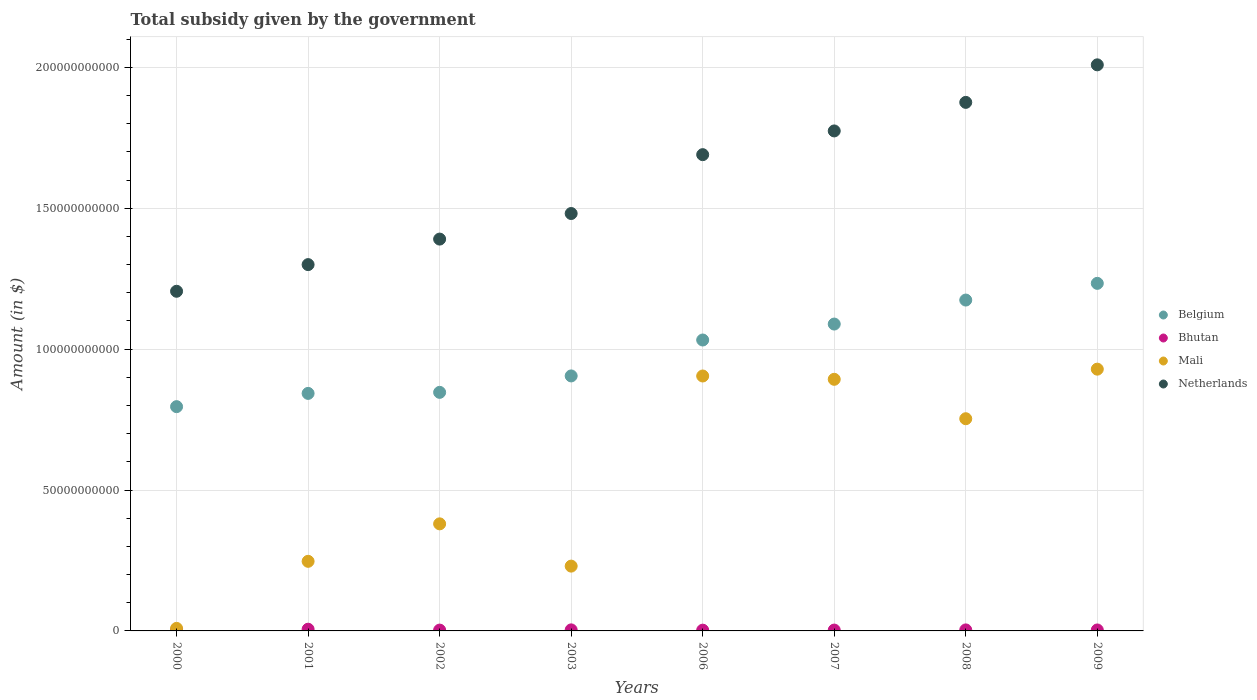How many different coloured dotlines are there?
Make the answer very short. 4. Is the number of dotlines equal to the number of legend labels?
Ensure brevity in your answer.  Yes. What is the total revenue collected by the government in Mali in 2008?
Give a very brief answer. 7.53e+1. Across all years, what is the maximum total revenue collected by the government in Mali?
Your answer should be very brief. 9.29e+1. Across all years, what is the minimum total revenue collected by the government in Belgium?
Provide a succinct answer. 7.96e+1. In which year was the total revenue collected by the government in Belgium minimum?
Provide a succinct answer. 2000. What is the total total revenue collected by the government in Belgium in the graph?
Provide a short and direct response. 7.92e+11. What is the difference between the total revenue collected by the government in Netherlands in 2001 and that in 2002?
Make the answer very short. -9.06e+09. What is the difference between the total revenue collected by the government in Netherlands in 2002 and the total revenue collected by the government in Mali in 2003?
Provide a succinct answer. 1.16e+11. What is the average total revenue collected by the government in Bhutan per year?
Your response must be concise. 3.51e+08. In the year 2003, what is the difference between the total revenue collected by the government in Mali and total revenue collected by the government in Netherlands?
Your response must be concise. -1.25e+11. What is the ratio of the total revenue collected by the government in Mali in 2003 to that in 2006?
Offer a very short reply. 0.25. Is the difference between the total revenue collected by the government in Mali in 2000 and 2002 greater than the difference between the total revenue collected by the government in Netherlands in 2000 and 2002?
Your answer should be compact. No. What is the difference between the highest and the second highest total revenue collected by the government in Bhutan?
Make the answer very short. 2.35e+08. What is the difference between the highest and the lowest total revenue collected by the government in Bhutan?
Offer a very short reply. 3.51e+08. Is it the case that in every year, the sum of the total revenue collected by the government in Mali and total revenue collected by the government in Belgium  is greater than the sum of total revenue collected by the government in Bhutan and total revenue collected by the government in Netherlands?
Offer a terse response. No. Is it the case that in every year, the sum of the total revenue collected by the government in Bhutan and total revenue collected by the government in Mali  is greater than the total revenue collected by the government in Netherlands?
Provide a succinct answer. No. How many dotlines are there?
Keep it short and to the point. 4. Are the values on the major ticks of Y-axis written in scientific E-notation?
Provide a short and direct response. No. Does the graph contain any zero values?
Make the answer very short. No. Does the graph contain grids?
Provide a succinct answer. Yes. Where does the legend appear in the graph?
Keep it short and to the point. Center right. How are the legend labels stacked?
Keep it short and to the point. Vertical. What is the title of the graph?
Make the answer very short. Total subsidy given by the government. Does "Bolivia" appear as one of the legend labels in the graph?
Ensure brevity in your answer.  No. What is the label or title of the X-axis?
Make the answer very short. Years. What is the label or title of the Y-axis?
Ensure brevity in your answer.  Amount (in $). What is the Amount (in $) of Belgium in 2000?
Ensure brevity in your answer.  7.96e+1. What is the Amount (in $) in Bhutan in 2000?
Offer a very short reply. 2.56e+08. What is the Amount (in $) in Mali in 2000?
Ensure brevity in your answer.  9.00e+08. What is the Amount (in $) of Netherlands in 2000?
Ensure brevity in your answer.  1.21e+11. What is the Amount (in $) in Belgium in 2001?
Keep it short and to the point. 8.43e+1. What is the Amount (in $) of Bhutan in 2001?
Your answer should be very brief. 6.07e+08. What is the Amount (in $) of Mali in 2001?
Provide a short and direct response. 2.47e+1. What is the Amount (in $) of Netherlands in 2001?
Your answer should be very brief. 1.30e+11. What is the Amount (in $) in Belgium in 2002?
Offer a very short reply. 8.47e+1. What is the Amount (in $) of Bhutan in 2002?
Give a very brief answer. 2.94e+08. What is the Amount (in $) in Mali in 2002?
Ensure brevity in your answer.  3.80e+1. What is the Amount (in $) in Netherlands in 2002?
Your answer should be very brief. 1.39e+11. What is the Amount (in $) in Belgium in 2003?
Your response must be concise. 9.05e+1. What is the Amount (in $) in Bhutan in 2003?
Make the answer very short. 3.72e+08. What is the Amount (in $) of Mali in 2003?
Ensure brevity in your answer.  2.30e+1. What is the Amount (in $) in Netherlands in 2003?
Make the answer very short. 1.48e+11. What is the Amount (in $) of Belgium in 2006?
Ensure brevity in your answer.  1.03e+11. What is the Amount (in $) in Bhutan in 2006?
Offer a very short reply. 2.71e+08. What is the Amount (in $) of Mali in 2006?
Your answer should be very brief. 9.05e+1. What is the Amount (in $) of Netherlands in 2006?
Make the answer very short. 1.69e+11. What is the Amount (in $) of Belgium in 2007?
Your response must be concise. 1.09e+11. What is the Amount (in $) of Bhutan in 2007?
Your answer should be compact. 3.05e+08. What is the Amount (in $) in Mali in 2007?
Give a very brief answer. 8.93e+1. What is the Amount (in $) of Netherlands in 2007?
Your response must be concise. 1.77e+11. What is the Amount (in $) of Belgium in 2008?
Ensure brevity in your answer.  1.17e+11. What is the Amount (in $) of Bhutan in 2008?
Provide a succinct answer. 3.60e+08. What is the Amount (in $) of Mali in 2008?
Make the answer very short. 7.53e+1. What is the Amount (in $) in Netherlands in 2008?
Make the answer very short. 1.88e+11. What is the Amount (in $) in Belgium in 2009?
Your answer should be compact. 1.23e+11. What is the Amount (in $) of Bhutan in 2009?
Your response must be concise. 3.42e+08. What is the Amount (in $) of Mali in 2009?
Provide a short and direct response. 9.29e+1. What is the Amount (in $) of Netherlands in 2009?
Offer a terse response. 2.01e+11. Across all years, what is the maximum Amount (in $) in Belgium?
Keep it short and to the point. 1.23e+11. Across all years, what is the maximum Amount (in $) of Bhutan?
Your response must be concise. 6.07e+08. Across all years, what is the maximum Amount (in $) of Mali?
Your answer should be compact. 9.29e+1. Across all years, what is the maximum Amount (in $) in Netherlands?
Your answer should be very brief. 2.01e+11. Across all years, what is the minimum Amount (in $) of Belgium?
Your response must be concise. 7.96e+1. Across all years, what is the minimum Amount (in $) of Bhutan?
Offer a very short reply. 2.56e+08. Across all years, what is the minimum Amount (in $) of Mali?
Provide a short and direct response. 9.00e+08. Across all years, what is the minimum Amount (in $) in Netherlands?
Make the answer very short. 1.21e+11. What is the total Amount (in $) of Belgium in the graph?
Provide a succinct answer. 7.92e+11. What is the total Amount (in $) in Bhutan in the graph?
Make the answer very short. 2.80e+09. What is the total Amount (in $) in Mali in the graph?
Keep it short and to the point. 4.35e+11. What is the total Amount (in $) in Netherlands in the graph?
Offer a very short reply. 1.27e+12. What is the difference between the Amount (in $) of Belgium in 2000 and that in 2001?
Your answer should be very brief. -4.70e+09. What is the difference between the Amount (in $) of Bhutan in 2000 and that in 2001?
Keep it short and to the point. -3.51e+08. What is the difference between the Amount (in $) of Mali in 2000 and that in 2001?
Your response must be concise. -2.38e+1. What is the difference between the Amount (in $) of Netherlands in 2000 and that in 2001?
Offer a very short reply. -9.46e+09. What is the difference between the Amount (in $) in Belgium in 2000 and that in 2002?
Provide a short and direct response. -5.08e+09. What is the difference between the Amount (in $) of Bhutan in 2000 and that in 2002?
Provide a short and direct response. -3.80e+07. What is the difference between the Amount (in $) in Mali in 2000 and that in 2002?
Provide a succinct answer. -3.71e+1. What is the difference between the Amount (in $) of Netherlands in 2000 and that in 2002?
Keep it short and to the point. -1.85e+1. What is the difference between the Amount (in $) in Belgium in 2000 and that in 2003?
Your response must be concise. -1.09e+1. What is the difference between the Amount (in $) in Bhutan in 2000 and that in 2003?
Your answer should be compact. -1.16e+08. What is the difference between the Amount (in $) in Mali in 2000 and that in 2003?
Give a very brief answer. -2.21e+1. What is the difference between the Amount (in $) in Netherlands in 2000 and that in 2003?
Your answer should be compact. -2.76e+1. What is the difference between the Amount (in $) in Belgium in 2000 and that in 2006?
Provide a succinct answer. -2.37e+1. What is the difference between the Amount (in $) of Bhutan in 2000 and that in 2006?
Keep it short and to the point. -1.47e+07. What is the difference between the Amount (in $) of Mali in 2000 and that in 2006?
Offer a terse response. -8.96e+1. What is the difference between the Amount (in $) of Netherlands in 2000 and that in 2006?
Keep it short and to the point. -4.85e+1. What is the difference between the Amount (in $) of Belgium in 2000 and that in 2007?
Offer a very short reply. -2.93e+1. What is the difference between the Amount (in $) in Bhutan in 2000 and that in 2007?
Give a very brief answer. -4.88e+07. What is the difference between the Amount (in $) of Mali in 2000 and that in 2007?
Make the answer very short. -8.84e+1. What is the difference between the Amount (in $) in Netherlands in 2000 and that in 2007?
Provide a succinct answer. -5.69e+1. What is the difference between the Amount (in $) of Belgium in 2000 and that in 2008?
Keep it short and to the point. -3.78e+1. What is the difference between the Amount (in $) in Bhutan in 2000 and that in 2008?
Your answer should be very brief. -1.04e+08. What is the difference between the Amount (in $) in Mali in 2000 and that in 2008?
Give a very brief answer. -7.44e+1. What is the difference between the Amount (in $) in Netherlands in 2000 and that in 2008?
Provide a succinct answer. -6.70e+1. What is the difference between the Amount (in $) of Belgium in 2000 and that in 2009?
Ensure brevity in your answer.  -4.38e+1. What is the difference between the Amount (in $) in Bhutan in 2000 and that in 2009?
Offer a very short reply. -8.59e+07. What is the difference between the Amount (in $) of Mali in 2000 and that in 2009?
Your answer should be compact. -9.20e+1. What is the difference between the Amount (in $) in Netherlands in 2000 and that in 2009?
Offer a terse response. -8.04e+1. What is the difference between the Amount (in $) in Belgium in 2001 and that in 2002?
Your answer should be very brief. -3.72e+08. What is the difference between the Amount (in $) in Bhutan in 2001 and that in 2002?
Offer a very short reply. 3.13e+08. What is the difference between the Amount (in $) in Mali in 2001 and that in 2002?
Make the answer very short. -1.33e+1. What is the difference between the Amount (in $) in Netherlands in 2001 and that in 2002?
Offer a very short reply. -9.06e+09. What is the difference between the Amount (in $) in Belgium in 2001 and that in 2003?
Ensure brevity in your answer.  -6.20e+09. What is the difference between the Amount (in $) in Bhutan in 2001 and that in 2003?
Keep it short and to the point. 2.35e+08. What is the difference between the Amount (in $) in Mali in 2001 and that in 2003?
Make the answer very short. 1.70e+09. What is the difference between the Amount (in $) of Netherlands in 2001 and that in 2003?
Offer a terse response. -1.81e+1. What is the difference between the Amount (in $) in Belgium in 2001 and that in 2006?
Keep it short and to the point. -1.90e+1. What is the difference between the Amount (in $) in Bhutan in 2001 and that in 2006?
Offer a very short reply. 3.36e+08. What is the difference between the Amount (in $) of Mali in 2001 and that in 2006?
Make the answer very short. -6.58e+1. What is the difference between the Amount (in $) in Netherlands in 2001 and that in 2006?
Provide a succinct answer. -3.90e+1. What is the difference between the Amount (in $) in Belgium in 2001 and that in 2007?
Give a very brief answer. -2.46e+1. What is the difference between the Amount (in $) of Bhutan in 2001 and that in 2007?
Ensure brevity in your answer.  3.02e+08. What is the difference between the Amount (in $) in Mali in 2001 and that in 2007?
Offer a terse response. -6.46e+1. What is the difference between the Amount (in $) in Netherlands in 2001 and that in 2007?
Make the answer very short. -4.74e+1. What is the difference between the Amount (in $) in Belgium in 2001 and that in 2008?
Your answer should be very brief. -3.31e+1. What is the difference between the Amount (in $) of Bhutan in 2001 and that in 2008?
Give a very brief answer. 2.47e+08. What is the difference between the Amount (in $) of Mali in 2001 and that in 2008?
Offer a terse response. -5.06e+1. What is the difference between the Amount (in $) of Netherlands in 2001 and that in 2008?
Provide a short and direct response. -5.76e+1. What is the difference between the Amount (in $) of Belgium in 2001 and that in 2009?
Provide a succinct answer. -3.91e+1. What is the difference between the Amount (in $) of Bhutan in 2001 and that in 2009?
Make the answer very short. 2.65e+08. What is the difference between the Amount (in $) in Mali in 2001 and that in 2009?
Your answer should be very brief. -6.82e+1. What is the difference between the Amount (in $) in Netherlands in 2001 and that in 2009?
Provide a succinct answer. -7.09e+1. What is the difference between the Amount (in $) of Belgium in 2002 and that in 2003?
Your answer should be compact. -5.83e+09. What is the difference between the Amount (in $) in Bhutan in 2002 and that in 2003?
Give a very brief answer. -7.80e+07. What is the difference between the Amount (in $) in Mali in 2002 and that in 2003?
Your response must be concise. 1.50e+1. What is the difference between the Amount (in $) in Netherlands in 2002 and that in 2003?
Provide a succinct answer. -9.08e+09. What is the difference between the Amount (in $) of Belgium in 2002 and that in 2006?
Your response must be concise. -1.86e+1. What is the difference between the Amount (in $) in Bhutan in 2002 and that in 2006?
Make the answer very short. 2.33e+07. What is the difference between the Amount (in $) in Mali in 2002 and that in 2006?
Your answer should be compact. -5.25e+1. What is the difference between the Amount (in $) in Netherlands in 2002 and that in 2006?
Offer a terse response. -3.00e+1. What is the difference between the Amount (in $) of Belgium in 2002 and that in 2007?
Provide a succinct answer. -2.42e+1. What is the difference between the Amount (in $) of Bhutan in 2002 and that in 2007?
Offer a terse response. -1.08e+07. What is the difference between the Amount (in $) of Mali in 2002 and that in 2007?
Make the answer very short. -5.13e+1. What is the difference between the Amount (in $) of Netherlands in 2002 and that in 2007?
Your answer should be compact. -3.84e+1. What is the difference between the Amount (in $) in Belgium in 2002 and that in 2008?
Keep it short and to the point. -3.28e+1. What is the difference between the Amount (in $) of Bhutan in 2002 and that in 2008?
Keep it short and to the point. -6.64e+07. What is the difference between the Amount (in $) of Mali in 2002 and that in 2008?
Ensure brevity in your answer.  -3.73e+1. What is the difference between the Amount (in $) of Netherlands in 2002 and that in 2008?
Provide a short and direct response. -4.85e+1. What is the difference between the Amount (in $) of Belgium in 2002 and that in 2009?
Offer a very short reply. -3.87e+1. What is the difference between the Amount (in $) of Bhutan in 2002 and that in 2009?
Ensure brevity in your answer.  -4.79e+07. What is the difference between the Amount (in $) of Mali in 2002 and that in 2009?
Offer a terse response. -5.49e+1. What is the difference between the Amount (in $) of Netherlands in 2002 and that in 2009?
Your answer should be compact. -6.18e+1. What is the difference between the Amount (in $) of Belgium in 2003 and that in 2006?
Make the answer very short. -1.28e+1. What is the difference between the Amount (in $) in Bhutan in 2003 and that in 2006?
Ensure brevity in your answer.  1.01e+08. What is the difference between the Amount (in $) in Mali in 2003 and that in 2006?
Provide a succinct answer. -6.75e+1. What is the difference between the Amount (in $) of Netherlands in 2003 and that in 2006?
Give a very brief answer. -2.09e+1. What is the difference between the Amount (in $) of Belgium in 2003 and that in 2007?
Your answer should be very brief. -1.84e+1. What is the difference between the Amount (in $) in Bhutan in 2003 and that in 2007?
Make the answer very short. 6.72e+07. What is the difference between the Amount (in $) in Mali in 2003 and that in 2007?
Ensure brevity in your answer.  -6.63e+1. What is the difference between the Amount (in $) in Netherlands in 2003 and that in 2007?
Make the answer very short. -2.93e+1. What is the difference between the Amount (in $) in Belgium in 2003 and that in 2008?
Ensure brevity in your answer.  -2.69e+1. What is the difference between the Amount (in $) in Bhutan in 2003 and that in 2008?
Your answer should be compact. 1.16e+07. What is the difference between the Amount (in $) in Mali in 2003 and that in 2008?
Ensure brevity in your answer.  -5.23e+1. What is the difference between the Amount (in $) of Netherlands in 2003 and that in 2008?
Offer a very short reply. -3.94e+1. What is the difference between the Amount (in $) of Belgium in 2003 and that in 2009?
Ensure brevity in your answer.  -3.29e+1. What is the difference between the Amount (in $) of Bhutan in 2003 and that in 2009?
Make the answer very short. 3.01e+07. What is the difference between the Amount (in $) in Mali in 2003 and that in 2009?
Ensure brevity in your answer.  -6.99e+1. What is the difference between the Amount (in $) of Netherlands in 2003 and that in 2009?
Your response must be concise. -5.28e+1. What is the difference between the Amount (in $) in Belgium in 2006 and that in 2007?
Your response must be concise. -5.66e+09. What is the difference between the Amount (in $) of Bhutan in 2006 and that in 2007?
Provide a short and direct response. -3.40e+07. What is the difference between the Amount (in $) of Mali in 2006 and that in 2007?
Your response must be concise. 1.17e+09. What is the difference between the Amount (in $) of Netherlands in 2006 and that in 2007?
Your answer should be compact. -8.42e+09. What is the difference between the Amount (in $) in Belgium in 2006 and that in 2008?
Provide a short and direct response. -1.42e+1. What is the difference between the Amount (in $) of Bhutan in 2006 and that in 2008?
Your response must be concise. -8.96e+07. What is the difference between the Amount (in $) of Mali in 2006 and that in 2008?
Give a very brief answer. 1.52e+1. What is the difference between the Amount (in $) of Netherlands in 2006 and that in 2008?
Provide a short and direct response. -1.86e+1. What is the difference between the Amount (in $) of Belgium in 2006 and that in 2009?
Offer a very short reply. -2.01e+1. What is the difference between the Amount (in $) in Bhutan in 2006 and that in 2009?
Make the answer very short. -7.12e+07. What is the difference between the Amount (in $) of Mali in 2006 and that in 2009?
Give a very brief answer. -2.43e+09. What is the difference between the Amount (in $) of Netherlands in 2006 and that in 2009?
Keep it short and to the point. -3.19e+1. What is the difference between the Amount (in $) in Belgium in 2007 and that in 2008?
Your response must be concise. -8.52e+09. What is the difference between the Amount (in $) of Bhutan in 2007 and that in 2008?
Ensure brevity in your answer.  -5.56e+07. What is the difference between the Amount (in $) of Mali in 2007 and that in 2008?
Your answer should be compact. 1.40e+1. What is the difference between the Amount (in $) of Netherlands in 2007 and that in 2008?
Offer a very short reply. -1.01e+1. What is the difference between the Amount (in $) in Belgium in 2007 and that in 2009?
Give a very brief answer. -1.44e+1. What is the difference between the Amount (in $) in Bhutan in 2007 and that in 2009?
Your answer should be very brief. -3.71e+07. What is the difference between the Amount (in $) of Mali in 2007 and that in 2009?
Offer a terse response. -3.60e+09. What is the difference between the Amount (in $) in Netherlands in 2007 and that in 2009?
Give a very brief answer. -2.35e+1. What is the difference between the Amount (in $) in Belgium in 2008 and that in 2009?
Provide a succinct answer. -5.93e+09. What is the difference between the Amount (in $) of Bhutan in 2008 and that in 2009?
Ensure brevity in your answer.  1.85e+07. What is the difference between the Amount (in $) in Mali in 2008 and that in 2009?
Make the answer very short. -1.76e+1. What is the difference between the Amount (in $) in Netherlands in 2008 and that in 2009?
Offer a terse response. -1.33e+1. What is the difference between the Amount (in $) in Belgium in 2000 and the Amount (in $) in Bhutan in 2001?
Ensure brevity in your answer.  7.90e+1. What is the difference between the Amount (in $) in Belgium in 2000 and the Amount (in $) in Mali in 2001?
Keep it short and to the point. 5.49e+1. What is the difference between the Amount (in $) of Belgium in 2000 and the Amount (in $) of Netherlands in 2001?
Provide a succinct answer. -5.04e+1. What is the difference between the Amount (in $) in Bhutan in 2000 and the Amount (in $) in Mali in 2001?
Provide a succinct answer. -2.44e+1. What is the difference between the Amount (in $) in Bhutan in 2000 and the Amount (in $) in Netherlands in 2001?
Keep it short and to the point. -1.30e+11. What is the difference between the Amount (in $) of Mali in 2000 and the Amount (in $) of Netherlands in 2001?
Keep it short and to the point. -1.29e+11. What is the difference between the Amount (in $) of Belgium in 2000 and the Amount (in $) of Bhutan in 2002?
Provide a succinct answer. 7.93e+1. What is the difference between the Amount (in $) in Belgium in 2000 and the Amount (in $) in Mali in 2002?
Make the answer very short. 4.16e+1. What is the difference between the Amount (in $) of Belgium in 2000 and the Amount (in $) of Netherlands in 2002?
Offer a terse response. -5.95e+1. What is the difference between the Amount (in $) in Bhutan in 2000 and the Amount (in $) in Mali in 2002?
Make the answer very short. -3.77e+1. What is the difference between the Amount (in $) in Bhutan in 2000 and the Amount (in $) in Netherlands in 2002?
Offer a very short reply. -1.39e+11. What is the difference between the Amount (in $) of Mali in 2000 and the Amount (in $) of Netherlands in 2002?
Offer a very short reply. -1.38e+11. What is the difference between the Amount (in $) of Belgium in 2000 and the Amount (in $) of Bhutan in 2003?
Keep it short and to the point. 7.92e+1. What is the difference between the Amount (in $) in Belgium in 2000 and the Amount (in $) in Mali in 2003?
Your response must be concise. 5.66e+1. What is the difference between the Amount (in $) in Belgium in 2000 and the Amount (in $) in Netherlands in 2003?
Provide a short and direct response. -6.85e+1. What is the difference between the Amount (in $) of Bhutan in 2000 and the Amount (in $) of Mali in 2003?
Ensure brevity in your answer.  -2.27e+1. What is the difference between the Amount (in $) in Bhutan in 2000 and the Amount (in $) in Netherlands in 2003?
Give a very brief answer. -1.48e+11. What is the difference between the Amount (in $) of Mali in 2000 and the Amount (in $) of Netherlands in 2003?
Your answer should be very brief. -1.47e+11. What is the difference between the Amount (in $) in Belgium in 2000 and the Amount (in $) in Bhutan in 2006?
Provide a short and direct response. 7.93e+1. What is the difference between the Amount (in $) of Belgium in 2000 and the Amount (in $) of Mali in 2006?
Offer a very short reply. -1.09e+1. What is the difference between the Amount (in $) of Belgium in 2000 and the Amount (in $) of Netherlands in 2006?
Make the answer very short. -8.94e+1. What is the difference between the Amount (in $) in Bhutan in 2000 and the Amount (in $) in Mali in 2006?
Keep it short and to the point. -9.02e+1. What is the difference between the Amount (in $) in Bhutan in 2000 and the Amount (in $) in Netherlands in 2006?
Keep it short and to the point. -1.69e+11. What is the difference between the Amount (in $) in Mali in 2000 and the Amount (in $) in Netherlands in 2006?
Provide a succinct answer. -1.68e+11. What is the difference between the Amount (in $) of Belgium in 2000 and the Amount (in $) of Bhutan in 2007?
Ensure brevity in your answer.  7.93e+1. What is the difference between the Amount (in $) in Belgium in 2000 and the Amount (in $) in Mali in 2007?
Ensure brevity in your answer.  -9.71e+09. What is the difference between the Amount (in $) in Belgium in 2000 and the Amount (in $) in Netherlands in 2007?
Give a very brief answer. -9.79e+1. What is the difference between the Amount (in $) in Bhutan in 2000 and the Amount (in $) in Mali in 2007?
Offer a terse response. -8.90e+1. What is the difference between the Amount (in $) in Bhutan in 2000 and the Amount (in $) in Netherlands in 2007?
Provide a short and direct response. -1.77e+11. What is the difference between the Amount (in $) in Mali in 2000 and the Amount (in $) in Netherlands in 2007?
Offer a very short reply. -1.77e+11. What is the difference between the Amount (in $) of Belgium in 2000 and the Amount (in $) of Bhutan in 2008?
Your answer should be compact. 7.92e+1. What is the difference between the Amount (in $) of Belgium in 2000 and the Amount (in $) of Mali in 2008?
Keep it short and to the point. 4.28e+09. What is the difference between the Amount (in $) in Belgium in 2000 and the Amount (in $) in Netherlands in 2008?
Provide a succinct answer. -1.08e+11. What is the difference between the Amount (in $) in Bhutan in 2000 and the Amount (in $) in Mali in 2008?
Your answer should be very brief. -7.51e+1. What is the difference between the Amount (in $) of Bhutan in 2000 and the Amount (in $) of Netherlands in 2008?
Your answer should be very brief. -1.87e+11. What is the difference between the Amount (in $) of Mali in 2000 and the Amount (in $) of Netherlands in 2008?
Give a very brief answer. -1.87e+11. What is the difference between the Amount (in $) in Belgium in 2000 and the Amount (in $) in Bhutan in 2009?
Provide a succinct answer. 7.93e+1. What is the difference between the Amount (in $) of Belgium in 2000 and the Amount (in $) of Mali in 2009?
Your answer should be compact. -1.33e+1. What is the difference between the Amount (in $) in Belgium in 2000 and the Amount (in $) in Netherlands in 2009?
Your answer should be very brief. -1.21e+11. What is the difference between the Amount (in $) of Bhutan in 2000 and the Amount (in $) of Mali in 2009?
Keep it short and to the point. -9.26e+1. What is the difference between the Amount (in $) of Bhutan in 2000 and the Amount (in $) of Netherlands in 2009?
Your response must be concise. -2.01e+11. What is the difference between the Amount (in $) in Mali in 2000 and the Amount (in $) in Netherlands in 2009?
Offer a very short reply. -2.00e+11. What is the difference between the Amount (in $) in Belgium in 2001 and the Amount (in $) in Bhutan in 2002?
Your answer should be very brief. 8.40e+1. What is the difference between the Amount (in $) in Belgium in 2001 and the Amount (in $) in Mali in 2002?
Your answer should be very brief. 4.63e+1. What is the difference between the Amount (in $) in Belgium in 2001 and the Amount (in $) in Netherlands in 2002?
Provide a short and direct response. -5.48e+1. What is the difference between the Amount (in $) of Bhutan in 2001 and the Amount (in $) of Mali in 2002?
Your response must be concise. -3.74e+1. What is the difference between the Amount (in $) of Bhutan in 2001 and the Amount (in $) of Netherlands in 2002?
Your answer should be very brief. -1.38e+11. What is the difference between the Amount (in $) in Mali in 2001 and the Amount (in $) in Netherlands in 2002?
Provide a short and direct response. -1.14e+11. What is the difference between the Amount (in $) in Belgium in 2001 and the Amount (in $) in Bhutan in 2003?
Ensure brevity in your answer.  8.39e+1. What is the difference between the Amount (in $) of Belgium in 2001 and the Amount (in $) of Mali in 2003?
Your response must be concise. 6.13e+1. What is the difference between the Amount (in $) of Belgium in 2001 and the Amount (in $) of Netherlands in 2003?
Offer a terse response. -6.38e+1. What is the difference between the Amount (in $) in Bhutan in 2001 and the Amount (in $) in Mali in 2003?
Keep it short and to the point. -2.24e+1. What is the difference between the Amount (in $) of Bhutan in 2001 and the Amount (in $) of Netherlands in 2003?
Make the answer very short. -1.48e+11. What is the difference between the Amount (in $) in Mali in 2001 and the Amount (in $) in Netherlands in 2003?
Provide a succinct answer. -1.23e+11. What is the difference between the Amount (in $) of Belgium in 2001 and the Amount (in $) of Bhutan in 2006?
Make the answer very short. 8.40e+1. What is the difference between the Amount (in $) of Belgium in 2001 and the Amount (in $) of Mali in 2006?
Your answer should be very brief. -6.18e+09. What is the difference between the Amount (in $) of Belgium in 2001 and the Amount (in $) of Netherlands in 2006?
Keep it short and to the point. -8.47e+1. What is the difference between the Amount (in $) in Bhutan in 2001 and the Amount (in $) in Mali in 2006?
Your answer should be very brief. -8.99e+1. What is the difference between the Amount (in $) in Bhutan in 2001 and the Amount (in $) in Netherlands in 2006?
Make the answer very short. -1.68e+11. What is the difference between the Amount (in $) of Mali in 2001 and the Amount (in $) of Netherlands in 2006?
Ensure brevity in your answer.  -1.44e+11. What is the difference between the Amount (in $) of Belgium in 2001 and the Amount (in $) of Bhutan in 2007?
Provide a short and direct response. 8.40e+1. What is the difference between the Amount (in $) of Belgium in 2001 and the Amount (in $) of Mali in 2007?
Your answer should be compact. -5.00e+09. What is the difference between the Amount (in $) of Belgium in 2001 and the Amount (in $) of Netherlands in 2007?
Ensure brevity in your answer.  -9.31e+1. What is the difference between the Amount (in $) of Bhutan in 2001 and the Amount (in $) of Mali in 2007?
Provide a short and direct response. -8.87e+1. What is the difference between the Amount (in $) in Bhutan in 2001 and the Amount (in $) in Netherlands in 2007?
Provide a succinct answer. -1.77e+11. What is the difference between the Amount (in $) in Mali in 2001 and the Amount (in $) in Netherlands in 2007?
Ensure brevity in your answer.  -1.53e+11. What is the difference between the Amount (in $) in Belgium in 2001 and the Amount (in $) in Bhutan in 2008?
Provide a short and direct response. 8.39e+1. What is the difference between the Amount (in $) of Belgium in 2001 and the Amount (in $) of Mali in 2008?
Offer a terse response. 8.99e+09. What is the difference between the Amount (in $) in Belgium in 2001 and the Amount (in $) in Netherlands in 2008?
Keep it short and to the point. -1.03e+11. What is the difference between the Amount (in $) of Bhutan in 2001 and the Amount (in $) of Mali in 2008?
Your response must be concise. -7.47e+1. What is the difference between the Amount (in $) of Bhutan in 2001 and the Amount (in $) of Netherlands in 2008?
Ensure brevity in your answer.  -1.87e+11. What is the difference between the Amount (in $) in Mali in 2001 and the Amount (in $) in Netherlands in 2008?
Keep it short and to the point. -1.63e+11. What is the difference between the Amount (in $) of Belgium in 2001 and the Amount (in $) of Bhutan in 2009?
Make the answer very short. 8.40e+1. What is the difference between the Amount (in $) of Belgium in 2001 and the Amount (in $) of Mali in 2009?
Your answer should be very brief. -8.61e+09. What is the difference between the Amount (in $) in Belgium in 2001 and the Amount (in $) in Netherlands in 2009?
Offer a very short reply. -1.17e+11. What is the difference between the Amount (in $) in Bhutan in 2001 and the Amount (in $) in Mali in 2009?
Offer a terse response. -9.23e+1. What is the difference between the Amount (in $) of Bhutan in 2001 and the Amount (in $) of Netherlands in 2009?
Keep it short and to the point. -2.00e+11. What is the difference between the Amount (in $) in Mali in 2001 and the Amount (in $) in Netherlands in 2009?
Your response must be concise. -1.76e+11. What is the difference between the Amount (in $) of Belgium in 2002 and the Amount (in $) of Bhutan in 2003?
Keep it short and to the point. 8.43e+1. What is the difference between the Amount (in $) in Belgium in 2002 and the Amount (in $) in Mali in 2003?
Offer a very short reply. 6.17e+1. What is the difference between the Amount (in $) in Belgium in 2002 and the Amount (in $) in Netherlands in 2003?
Your response must be concise. -6.35e+1. What is the difference between the Amount (in $) in Bhutan in 2002 and the Amount (in $) in Mali in 2003?
Keep it short and to the point. -2.27e+1. What is the difference between the Amount (in $) in Bhutan in 2002 and the Amount (in $) in Netherlands in 2003?
Make the answer very short. -1.48e+11. What is the difference between the Amount (in $) in Mali in 2002 and the Amount (in $) in Netherlands in 2003?
Offer a terse response. -1.10e+11. What is the difference between the Amount (in $) in Belgium in 2002 and the Amount (in $) in Bhutan in 2006?
Ensure brevity in your answer.  8.44e+1. What is the difference between the Amount (in $) in Belgium in 2002 and the Amount (in $) in Mali in 2006?
Offer a very short reply. -5.81e+09. What is the difference between the Amount (in $) in Belgium in 2002 and the Amount (in $) in Netherlands in 2006?
Offer a very short reply. -8.44e+1. What is the difference between the Amount (in $) in Bhutan in 2002 and the Amount (in $) in Mali in 2006?
Give a very brief answer. -9.02e+1. What is the difference between the Amount (in $) of Bhutan in 2002 and the Amount (in $) of Netherlands in 2006?
Provide a short and direct response. -1.69e+11. What is the difference between the Amount (in $) of Mali in 2002 and the Amount (in $) of Netherlands in 2006?
Your response must be concise. -1.31e+11. What is the difference between the Amount (in $) of Belgium in 2002 and the Amount (in $) of Bhutan in 2007?
Your answer should be very brief. 8.44e+1. What is the difference between the Amount (in $) of Belgium in 2002 and the Amount (in $) of Mali in 2007?
Make the answer very short. -4.63e+09. What is the difference between the Amount (in $) in Belgium in 2002 and the Amount (in $) in Netherlands in 2007?
Your answer should be compact. -9.28e+1. What is the difference between the Amount (in $) of Bhutan in 2002 and the Amount (in $) of Mali in 2007?
Ensure brevity in your answer.  -8.90e+1. What is the difference between the Amount (in $) of Bhutan in 2002 and the Amount (in $) of Netherlands in 2007?
Ensure brevity in your answer.  -1.77e+11. What is the difference between the Amount (in $) of Mali in 2002 and the Amount (in $) of Netherlands in 2007?
Your answer should be very brief. -1.39e+11. What is the difference between the Amount (in $) of Belgium in 2002 and the Amount (in $) of Bhutan in 2008?
Your answer should be very brief. 8.43e+1. What is the difference between the Amount (in $) in Belgium in 2002 and the Amount (in $) in Mali in 2008?
Keep it short and to the point. 9.36e+09. What is the difference between the Amount (in $) of Belgium in 2002 and the Amount (in $) of Netherlands in 2008?
Give a very brief answer. -1.03e+11. What is the difference between the Amount (in $) of Bhutan in 2002 and the Amount (in $) of Mali in 2008?
Your answer should be very brief. -7.50e+1. What is the difference between the Amount (in $) of Bhutan in 2002 and the Amount (in $) of Netherlands in 2008?
Ensure brevity in your answer.  -1.87e+11. What is the difference between the Amount (in $) of Mali in 2002 and the Amount (in $) of Netherlands in 2008?
Your answer should be very brief. -1.50e+11. What is the difference between the Amount (in $) of Belgium in 2002 and the Amount (in $) of Bhutan in 2009?
Your answer should be compact. 8.43e+1. What is the difference between the Amount (in $) of Belgium in 2002 and the Amount (in $) of Mali in 2009?
Make the answer very short. -8.23e+09. What is the difference between the Amount (in $) in Belgium in 2002 and the Amount (in $) in Netherlands in 2009?
Offer a very short reply. -1.16e+11. What is the difference between the Amount (in $) in Bhutan in 2002 and the Amount (in $) in Mali in 2009?
Your response must be concise. -9.26e+1. What is the difference between the Amount (in $) in Bhutan in 2002 and the Amount (in $) in Netherlands in 2009?
Offer a very short reply. -2.01e+11. What is the difference between the Amount (in $) of Mali in 2002 and the Amount (in $) of Netherlands in 2009?
Your answer should be compact. -1.63e+11. What is the difference between the Amount (in $) in Belgium in 2003 and the Amount (in $) in Bhutan in 2006?
Your answer should be very brief. 9.02e+1. What is the difference between the Amount (in $) of Belgium in 2003 and the Amount (in $) of Mali in 2006?
Ensure brevity in your answer.  2.39e+07. What is the difference between the Amount (in $) in Belgium in 2003 and the Amount (in $) in Netherlands in 2006?
Give a very brief answer. -7.85e+1. What is the difference between the Amount (in $) in Bhutan in 2003 and the Amount (in $) in Mali in 2006?
Ensure brevity in your answer.  -9.01e+1. What is the difference between the Amount (in $) in Bhutan in 2003 and the Amount (in $) in Netherlands in 2006?
Make the answer very short. -1.69e+11. What is the difference between the Amount (in $) of Mali in 2003 and the Amount (in $) of Netherlands in 2006?
Make the answer very short. -1.46e+11. What is the difference between the Amount (in $) in Belgium in 2003 and the Amount (in $) in Bhutan in 2007?
Your answer should be very brief. 9.02e+1. What is the difference between the Amount (in $) of Belgium in 2003 and the Amount (in $) of Mali in 2007?
Provide a short and direct response. 1.20e+09. What is the difference between the Amount (in $) in Belgium in 2003 and the Amount (in $) in Netherlands in 2007?
Ensure brevity in your answer.  -8.69e+1. What is the difference between the Amount (in $) of Bhutan in 2003 and the Amount (in $) of Mali in 2007?
Your answer should be compact. -8.89e+1. What is the difference between the Amount (in $) of Bhutan in 2003 and the Amount (in $) of Netherlands in 2007?
Make the answer very short. -1.77e+11. What is the difference between the Amount (in $) of Mali in 2003 and the Amount (in $) of Netherlands in 2007?
Offer a very short reply. -1.54e+11. What is the difference between the Amount (in $) in Belgium in 2003 and the Amount (in $) in Bhutan in 2008?
Your answer should be very brief. 9.01e+1. What is the difference between the Amount (in $) of Belgium in 2003 and the Amount (in $) of Mali in 2008?
Your answer should be very brief. 1.52e+1. What is the difference between the Amount (in $) in Belgium in 2003 and the Amount (in $) in Netherlands in 2008?
Give a very brief answer. -9.71e+1. What is the difference between the Amount (in $) of Bhutan in 2003 and the Amount (in $) of Mali in 2008?
Your response must be concise. -7.49e+1. What is the difference between the Amount (in $) of Bhutan in 2003 and the Amount (in $) of Netherlands in 2008?
Offer a very short reply. -1.87e+11. What is the difference between the Amount (in $) of Mali in 2003 and the Amount (in $) of Netherlands in 2008?
Make the answer very short. -1.65e+11. What is the difference between the Amount (in $) in Belgium in 2003 and the Amount (in $) in Bhutan in 2009?
Make the answer very short. 9.02e+1. What is the difference between the Amount (in $) in Belgium in 2003 and the Amount (in $) in Mali in 2009?
Provide a short and direct response. -2.40e+09. What is the difference between the Amount (in $) in Belgium in 2003 and the Amount (in $) in Netherlands in 2009?
Ensure brevity in your answer.  -1.10e+11. What is the difference between the Amount (in $) in Bhutan in 2003 and the Amount (in $) in Mali in 2009?
Your answer should be compact. -9.25e+1. What is the difference between the Amount (in $) in Bhutan in 2003 and the Amount (in $) in Netherlands in 2009?
Keep it short and to the point. -2.01e+11. What is the difference between the Amount (in $) of Mali in 2003 and the Amount (in $) of Netherlands in 2009?
Your answer should be very brief. -1.78e+11. What is the difference between the Amount (in $) in Belgium in 2006 and the Amount (in $) in Bhutan in 2007?
Provide a short and direct response. 1.03e+11. What is the difference between the Amount (in $) of Belgium in 2006 and the Amount (in $) of Mali in 2007?
Ensure brevity in your answer.  1.39e+1. What is the difference between the Amount (in $) of Belgium in 2006 and the Amount (in $) of Netherlands in 2007?
Give a very brief answer. -7.42e+1. What is the difference between the Amount (in $) in Bhutan in 2006 and the Amount (in $) in Mali in 2007?
Make the answer very short. -8.90e+1. What is the difference between the Amount (in $) in Bhutan in 2006 and the Amount (in $) in Netherlands in 2007?
Keep it short and to the point. -1.77e+11. What is the difference between the Amount (in $) in Mali in 2006 and the Amount (in $) in Netherlands in 2007?
Provide a short and direct response. -8.70e+1. What is the difference between the Amount (in $) in Belgium in 2006 and the Amount (in $) in Bhutan in 2008?
Offer a very short reply. 1.03e+11. What is the difference between the Amount (in $) in Belgium in 2006 and the Amount (in $) in Mali in 2008?
Your answer should be compact. 2.79e+1. What is the difference between the Amount (in $) in Belgium in 2006 and the Amount (in $) in Netherlands in 2008?
Offer a very short reply. -8.43e+1. What is the difference between the Amount (in $) in Bhutan in 2006 and the Amount (in $) in Mali in 2008?
Your response must be concise. -7.50e+1. What is the difference between the Amount (in $) of Bhutan in 2006 and the Amount (in $) of Netherlands in 2008?
Give a very brief answer. -1.87e+11. What is the difference between the Amount (in $) in Mali in 2006 and the Amount (in $) in Netherlands in 2008?
Your answer should be very brief. -9.71e+1. What is the difference between the Amount (in $) in Belgium in 2006 and the Amount (in $) in Bhutan in 2009?
Make the answer very short. 1.03e+11. What is the difference between the Amount (in $) of Belgium in 2006 and the Amount (in $) of Mali in 2009?
Give a very brief answer. 1.03e+1. What is the difference between the Amount (in $) in Belgium in 2006 and the Amount (in $) in Netherlands in 2009?
Make the answer very short. -9.77e+1. What is the difference between the Amount (in $) of Bhutan in 2006 and the Amount (in $) of Mali in 2009?
Keep it short and to the point. -9.26e+1. What is the difference between the Amount (in $) in Bhutan in 2006 and the Amount (in $) in Netherlands in 2009?
Provide a short and direct response. -2.01e+11. What is the difference between the Amount (in $) of Mali in 2006 and the Amount (in $) of Netherlands in 2009?
Ensure brevity in your answer.  -1.10e+11. What is the difference between the Amount (in $) of Belgium in 2007 and the Amount (in $) of Bhutan in 2008?
Your answer should be very brief. 1.09e+11. What is the difference between the Amount (in $) in Belgium in 2007 and the Amount (in $) in Mali in 2008?
Your response must be concise. 3.36e+1. What is the difference between the Amount (in $) of Belgium in 2007 and the Amount (in $) of Netherlands in 2008?
Ensure brevity in your answer.  -7.87e+1. What is the difference between the Amount (in $) of Bhutan in 2007 and the Amount (in $) of Mali in 2008?
Keep it short and to the point. -7.50e+1. What is the difference between the Amount (in $) of Bhutan in 2007 and the Amount (in $) of Netherlands in 2008?
Provide a succinct answer. -1.87e+11. What is the difference between the Amount (in $) in Mali in 2007 and the Amount (in $) in Netherlands in 2008?
Keep it short and to the point. -9.83e+1. What is the difference between the Amount (in $) of Belgium in 2007 and the Amount (in $) of Bhutan in 2009?
Offer a terse response. 1.09e+11. What is the difference between the Amount (in $) in Belgium in 2007 and the Amount (in $) in Mali in 2009?
Offer a terse response. 1.60e+1. What is the difference between the Amount (in $) in Belgium in 2007 and the Amount (in $) in Netherlands in 2009?
Offer a very short reply. -9.20e+1. What is the difference between the Amount (in $) of Bhutan in 2007 and the Amount (in $) of Mali in 2009?
Offer a very short reply. -9.26e+1. What is the difference between the Amount (in $) of Bhutan in 2007 and the Amount (in $) of Netherlands in 2009?
Keep it short and to the point. -2.01e+11. What is the difference between the Amount (in $) of Mali in 2007 and the Amount (in $) of Netherlands in 2009?
Offer a terse response. -1.12e+11. What is the difference between the Amount (in $) in Belgium in 2008 and the Amount (in $) in Bhutan in 2009?
Your answer should be compact. 1.17e+11. What is the difference between the Amount (in $) of Belgium in 2008 and the Amount (in $) of Mali in 2009?
Your answer should be compact. 2.45e+1. What is the difference between the Amount (in $) of Belgium in 2008 and the Amount (in $) of Netherlands in 2009?
Your answer should be compact. -8.35e+1. What is the difference between the Amount (in $) in Bhutan in 2008 and the Amount (in $) in Mali in 2009?
Offer a very short reply. -9.25e+1. What is the difference between the Amount (in $) of Bhutan in 2008 and the Amount (in $) of Netherlands in 2009?
Your response must be concise. -2.01e+11. What is the difference between the Amount (in $) of Mali in 2008 and the Amount (in $) of Netherlands in 2009?
Keep it short and to the point. -1.26e+11. What is the average Amount (in $) in Belgium per year?
Give a very brief answer. 9.90e+1. What is the average Amount (in $) of Bhutan per year?
Provide a succinct answer. 3.51e+08. What is the average Amount (in $) in Mali per year?
Your answer should be very brief. 5.43e+1. What is the average Amount (in $) in Netherlands per year?
Give a very brief answer. 1.59e+11. In the year 2000, what is the difference between the Amount (in $) of Belgium and Amount (in $) of Bhutan?
Your response must be concise. 7.93e+1. In the year 2000, what is the difference between the Amount (in $) of Belgium and Amount (in $) of Mali?
Your answer should be very brief. 7.87e+1. In the year 2000, what is the difference between the Amount (in $) in Belgium and Amount (in $) in Netherlands?
Your answer should be compact. -4.10e+1. In the year 2000, what is the difference between the Amount (in $) in Bhutan and Amount (in $) in Mali?
Your answer should be compact. -6.44e+08. In the year 2000, what is the difference between the Amount (in $) of Bhutan and Amount (in $) of Netherlands?
Give a very brief answer. -1.20e+11. In the year 2000, what is the difference between the Amount (in $) in Mali and Amount (in $) in Netherlands?
Your answer should be very brief. -1.20e+11. In the year 2001, what is the difference between the Amount (in $) in Belgium and Amount (in $) in Bhutan?
Offer a terse response. 8.37e+1. In the year 2001, what is the difference between the Amount (in $) of Belgium and Amount (in $) of Mali?
Your answer should be very brief. 5.96e+1. In the year 2001, what is the difference between the Amount (in $) in Belgium and Amount (in $) in Netherlands?
Offer a terse response. -4.57e+1. In the year 2001, what is the difference between the Amount (in $) in Bhutan and Amount (in $) in Mali?
Your answer should be very brief. -2.41e+1. In the year 2001, what is the difference between the Amount (in $) of Bhutan and Amount (in $) of Netherlands?
Offer a very short reply. -1.29e+11. In the year 2001, what is the difference between the Amount (in $) in Mali and Amount (in $) in Netherlands?
Offer a very short reply. -1.05e+11. In the year 2002, what is the difference between the Amount (in $) in Belgium and Amount (in $) in Bhutan?
Keep it short and to the point. 8.44e+1. In the year 2002, what is the difference between the Amount (in $) in Belgium and Amount (in $) in Mali?
Give a very brief answer. 4.67e+1. In the year 2002, what is the difference between the Amount (in $) in Belgium and Amount (in $) in Netherlands?
Ensure brevity in your answer.  -5.44e+1. In the year 2002, what is the difference between the Amount (in $) of Bhutan and Amount (in $) of Mali?
Your response must be concise. -3.77e+1. In the year 2002, what is the difference between the Amount (in $) in Bhutan and Amount (in $) in Netherlands?
Offer a very short reply. -1.39e+11. In the year 2002, what is the difference between the Amount (in $) of Mali and Amount (in $) of Netherlands?
Provide a short and direct response. -1.01e+11. In the year 2003, what is the difference between the Amount (in $) of Belgium and Amount (in $) of Bhutan?
Your response must be concise. 9.01e+1. In the year 2003, what is the difference between the Amount (in $) in Belgium and Amount (in $) in Mali?
Provide a short and direct response. 6.75e+1. In the year 2003, what is the difference between the Amount (in $) of Belgium and Amount (in $) of Netherlands?
Make the answer very short. -5.76e+1. In the year 2003, what is the difference between the Amount (in $) in Bhutan and Amount (in $) in Mali?
Provide a short and direct response. -2.26e+1. In the year 2003, what is the difference between the Amount (in $) of Bhutan and Amount (in $) of Netherlands?
Ensure brevity in your answer.  -1.48e+11. In the year 2003, what is the difference between the Amount (in $) of Mali and Amount (in $) of Netherlands?
Provide a succinct answer. -1.25e+11. In the year 2006, what is the difference between the Amount (in $) in Belgium and Amount (in $) in Bhutan?
Provide a succinct answer. 1.03e+11. In the year 2006, what is the difference between the Amount (in $) in Belgium and Amount (in $) in Mali?
Make the answer very short. 1.28e+1. In the year 2006, what is the difference between the Amount (in $) of Belgium and Amount (in $) of Netherlands?
Offer a terse response. -6.58e+1. In the year 2006, what is the difference between the Amount (in $) of Bhutan and Amount (in $) of Mali?
Keep it short and to the point. -9.02e+1. In the year 2006, what is the difference between the Amount (in $) of Bhutan and Amount (in $) of Netherlands?
Provide a short and direct response. -1.69e+11. In the year 2006, what is the difference between the Amount (in $) in Mali and Amount (in $) in Netherlands?
Make the answer very short. -7.86e+1. In the year 2007, what is the difference between the Amount (in $) in Belgium and Amount (in $) in Bhutan?
Make the answer very short. 1.09e+11. In the year 2007, what is the difference between the Amount (in $) in Belgium and Amount (in $) in Mali?
Ensure brevity in your answer.  1.96e+1. In the year 2007, what is the difference between the Amount (in $) of Belgium and Amount (in $) of Netherlands?
Make the answer very short. -6.85e+1. In the year 2007, what is the difference between the Amount (in $) in Bhutan and Amount (in $) in Mali?
Your response must be concise. -8.90e+1. In the year 2007, what is the difference between the Amount (in $) in Bhutan and Amount (in $) in Netherlands?
Offer a very short reply. -1.77e+11. In the year 2007, what is the difference between the Amount (in $) of Mali and Amount (in $) of Netherlands?
Your answer should be very brief. -8.81e+1. In the year 2008, what is the difference between the Amount (in $) in Belgium and Amount (in $) in Bhutan?
Ensure brevity in your answer.  1.17e+11. In the year 2008, what is the difference between the Amount (in $) in Belgium and Amount (in $) in Mali?
Your answer should be very brief. 4.21e+1. In the year 2008, what is the difference between the Amount (in $) in Belgium and Amount (in $) in Netherlands?
Provide a succinct answer. -7.02e+1. In the year 2008, what is the difference between the Amount (in $) in Bhutan and Amount (in $) in Mali?
Your response must be concise. -7.50e+1. In the year 2008, what is the difference between the Amount (in $) in Bhutan and Amount (in $) in Netherlands?
Keep it short and to the point. -1.87e+11. In the year 2008, what is the difference between the Amount (in $) of Mali and Amount (in $) of Netherlands?
Provide a short and direct response. -1.12e+11. In the year 2009, what is the difference between the Amount (in $) of Belgium and Amount (in $) of Bhutan?
Your response must be concise. 1.23e+11. In the year 2009, what is the difference between the Amount (in $) in Belgium and Amount (in $) in Mali?
Ensure brevity in your answer.  3.05e+1. In the year 2009, what is the difference between the Amount (in $) in Belgium and Amount (in $) in Netherlands?
Make the answer very short. -7.76e+1. In the year 2009, what is the difference between the Amount (in $) of Bhutan and Amount (in $) of Mali?
Your response must be concise. -9.26e+1. In the year 2009, what is the difference between the Amount (in $) in Bhutan and Amount (in $) in Netherlands?
Your answer should be compact. -2.01e+11. In the year 2009, what is the difference between the Amount (in $) of Mali and Amount (in $) of Netherlands?
Your response must be concise. -1.08e+11. What is the ratio of the Amount (in $) in Belgium in 2000 to that in 2001?
Provide a succinct answer. 0.94. What is the ratio of the Amount (in $) of Bhutan in 2000 to that in 2001?
Keep it short and to the point. 0.42. What is the ratio of the Amount (in $) in Mali in 2000 to that in 2001?
Offer a very short reply. 0.04. What is the ratio of the Amount (in $) of Netherlands in 2000 to that in 2001?
Make the answer very short. 0.93. What is the ratio of the Amount (in $) of Belgium in 2000 to that in 2002?
Provide a succinct answer. 0.94. What is the ratio of the Amount (in $) in Bhutan in 2000 to that in 2002?
Give a very brief answer. 0.87. What is the ratio of the Amount (in $) in Mali in 2000 to that in 2002?
Make the answer very short. 0.02. What is the ratio of the Amount (in $) in Netherlands in 2000 to that in 2002?
Offer a very short reply. 0.87. What is the ratio of the Amount (in $) of Belgium in 2000 to that in 2003?
Keep it short and to the point. 0.88. What is the ratio of the Amount (in $) in Bhutan in 2000 to that in 2003?
Ensure brevity in your answer.  0.69. What is the ratio of the Amount (in $) of Mali in 2000 to that in 2003?
Your response must be concise. 0.04. What is the ratio of the Amount (in $) in Netherlands in 2000 to that in 2003?
Give a very brief answer. 0.81. What is the ratio of the Amount (in $) in Belgium in 2000 to that in 2006?
Offer a very short reply. 0.77. What is the ratio of the Amount (in $) in Bhutan in 2000 to that in 2006?
Your answer should be very brief. 0.95. What is the ratio of the Amount (in $) of Mali in 2000 to that in 2006?
Your answer should be very brief. 0.01. What is the ratio of the Amount (in $) of Netherlands in 2000 to that in 2006?
Offer a terse response. 0.71. What is the ratio of the Amount (in $) in Belgium in 2000 to that in 2007?
Offer a very short reply. 0.73. What is the ratio of the Amount (in $) of Bhutan in 2000 to that in 2007?
Provide a succinct answer. 0.84. What is the ratio of the Amount (in $) of Mali in 2000 to that in 2007?
Offer a terse response. 0.01. What is the ratio of the Amount (in $) in Netherlands in 2000 to that in 2007?
Your answer should be very brief. 0.68. What is the ratio of the Amount (in $) of Belgium in 2000 to that in 2008?
Give a very brief answer. 0.68. What is the ratio of the Amount (in $) in Bhutan in 2000 to that in 2008?
Your answer should be compact. 0.71. What is the ratio of the Amount (in $) of Mali in 2000 to that in 2008?
Your answer should be compact. 0.01. What is the ratio of the Amount (in $) in Netherlands in 2000 to that in 2008?
Your answer should be compact. 0.64. What is the ratio of the Amount (in $) of Belgium in 2000 to that in 2009?
Ensure brevity in your answer.  0.65. What is the ratio of the Amount (in $) of Bhutan in 2000 to that in 2009?
Your response must be concise. 0.75. What is the ratio of the Amount (in $) in Mali in 2000 to that in 2009?
Your answer should be compact. 0.01. What is the ratio of the Amount (in $) in Netherlands in 2000 to that in 2009?
Your response must be concise. 0.6. What is the ratio of the Amount (in $) in Bhutan in 2001 to that in 2002?
Provide a short and direct response. 2.07. What is the ratio of the Amount (in $) of Mali in 2001 to that in 2002?
Your response must be concise. 0.65. What is the ratio of the Amount (in $) of Netherlands in 2001 to that in 2002?
Offer a terse response. 0.93. What is the ratio of the Amount (in $) in Belgium in 2001 to that in 2003?
Your response must be concise. 0.93. What is the ratio of the Amount (in $) of Bhutan in 2001 to that in 2003?
Offer a terse response. 1.63. What is the ratio of the Amount (in $) in Mali in 2001 to that in 2003?
Your response must be concise. 1.07. What is the ratio of the Amount (in $) of Netherlands in 2001 to that in 2003?
Your answer should be compact. 0.88. What is the ratio of the Amount (in $) of Belgium in 2001 to that in 2006?
Provide a short and direct response. 0.82. What is the ratio of the Amount (in $) in Bhutan in 2001 to that in 2006?
Offer a very short reply. 2.24. What is the ratio of the Amount (in $) in Mali in 2001 to that in 2006?
Make the answer very short. 0.27. What is the ratio of the Amount (in $) in Netherlands in 2001 to that in 2006?
Your answer should be compact. 0.77. What is the ratio of the Amount (in $) in Belgium in 2001 to that in 2007?
Your answer should be very brief. 0.77. What is the ratio of the Amount (in $) of Bhutan in 2001 to that in 2007?
Your answer should be very brief. 1.99. What is the ratio of the Amount (in $) in Mali in 2001 to that in 2007?
Your answer should be compact. 0.28. What is the ratio of the Amount (in $) of Netherlands in 2001 to that in 2007?
Keep it short and to the point. 0.73. What is the ratio of the Amount (in $) of Belgium in 2001 to that in 2008?
Offer a terse response. 0.72. What is the ratio of the Amount (in $) in Bhutan in 2001 to that in 2008?
Give a very brief answer. 1.68. What is the ratio of the Amount (in $) of Mali in 2001 to that in 2008?
Offer a terse response. 0.33. What is the ratio of the Amount (in $) of Netherlands in 2001 to that in 2008?
Make the answer very short. 0.69. What is the ratio of the Amount (in $) in Belgium in 2001 to that in 2009?
Offer a very short reply. 0.68. What is the ratio of the Amount (in $) of Bhutan in 2001 to that in 2009?
Give a very brief answer. 1.78. What is the ratio of the Amount (in $) in Mali in 2001 to that in 2009?
Your response must be concise. 0.27. What is the ratio of the Amount (in $) in Netherlands in 2001 to that in 2009?
Make the answer very short. 0.65. What is the ratio of the Amount (in $) in Belgium in 2002 to that in 2003?
Provide a succinct answer. 0.94. What is the ratio of the Amount (in $) in Bhutan in 2002 to that in 2003?
Keep it short and to the point. 0.79. What is the ratio of the Amount (in $) of Mali in 2002 to that in 2003?
Your response must be concise. 1.65. What is the ratio of the Amount (in $) in Netherlands in 2002 to that in 2003?
Provide a short and direct response. 0.94. What is the ratio of the Amount (in $) of Belgium in 2002 to that in 2006?
Your answer should be very brief. 0.82. What is the ratio of the Amount (in $) of Bhutan in 2002 to that in 2006?
Your answer should be very brief. 1.09. What is the ratio of the Amount (in $) in Mali in 2002 to that in 2006?
Provide a succinct answer. 0.42. What is the ratio of the Amount (in $) in Netherlands in 2002 to that in 2006?
Your response must be concise. 0.82. What is the ratio of the Amount (in $) in Belgium in 2002 to that in 2007?
Offer a very short reply. 0.78. What is the ratio of the Amount (in $) of Bhutan in 2002 to that in 2007?
Offer a very short reply. 0.96. What is the ratio of the Amount (in $) in Mali in 2002 to that in 2007?
Offer a very short reply. 0.43. What is the ratio of the Amount (in $) of Netherlands in 2002 to that in 2007?
Make the answer very short. 0.78. What is the ratio of the Amount (in $) of Belgium in 2002 to that in 2008?
Your answer should be very brief. 0.72. What is the ratio of the Amount (in $) of Bhutan in 2002 to that in 2008?
Give a very brief answer. 0.82. What is the ratio of the Amount (in $) in Mali in 2002 to that in 2008?
Your answer should be compact. 0.5. What is the ratio of the Amount (in $) of Netherlands in 2002 to that in 2008?
Keep it short and to the point. 0.74. What is the ratio of the Amount (in $) of Belgium in 2002 to that in 2009?
Give a very brief answer. 0.69. What is the ratio of the Amount (in $) of Bhutan in 2002 to that in 2009?
Your response must be concise. 0.86. What is the ratio of the Amount (in $) of Mali in 2002 to that in 2009?
Ensure brevity in your answer.  0.41. What is the ratio of the Amount (in $) of Netherlands in 2002 to that in 2009?
Your answer should be very brief. 0.69. What is the ratio of the Amount (in $) of Belgium in 2003 to that in 2006?
Make the answer very short. 0.88. What is the ratio of the Amount (in $) of Bhutan in 2003 to that in 2006?
Offer a very short reply. 1.37. What is the ratio of the Amount (in $) of Mali in 2003 to that in 2006?
Ensure brevity in your answer.  0.25. What is the ratio of the Amount (in $) in Netherlands in 2003 to that in 2006?
Keep it short and to the point. 0.88. What is the ratio of the Amount (in $) in Belgium in 2003 to that in 2007?
Provide a short and direct response. 0.83. What is the ratio of the Amount (in $) in Bhutan in 2003 to that in 2007?
Make the answer very short. 1.22. What is the ratio of the Amount (in $) in Mali in 2003 to that in 2007?
Offer a very short reply. 0.26. What is the ratio of the Amount (in $) in Netherlands in 2003 to that in 2007?
Offer a very short reply. 0.83. What is the ratio of the Amount (in $) of Belgium in 2003 to that in 2008?
Your answer should be compact. 0.77. What is the ratio of the Amount (in $) of Bhutan in 2003 to that in 2008?
Your answer should be compact. 1.03. What is the ratio of the Amount (in $) of Mali in 2003 to that in 2008?
Give a very brief answer. 0.31. What is the ratio of the Amount (in $) in Netherlands in 2003 to that in 2008?
Provide a short and direct response. 0.79. What is the ratio of the Amount (in $) in Belgium in 2003 to that in 2009?
Your answer should be very brief. 0.73. What is the ratio of the Amount (in $) in Bhutan in 2003 to that in 2009?
Keep it short and to the point. 1.09. What is the ratio of the Amount (in $) in Mali in 2003 to that in 2009?
Offer a very short reply. 0.25. What is the ratio of the Amount (in $) in Netherlands in 2003 to that in 2009?
Your answer should be very brief. 0.74. What is the ratio of the Amount (in $) in Belgium in 2006 to that in 2007?
Ensure brevity in your answer.  0.95. What is the ratio of the Amount (in $) in Bhutan in 2006 to that in 2007?
Your response must be concise. 0.89. What is the ratio of the Amount (in $) of Mali in 2006 to that in 2007?
Offer a very short reply. 1.01. What is the ratio of the Amount (in $) of Netherlands in 2006 to that in 2007?
Give a very brief answer. 0.95. What is the ratio of the Amount (in $) of Belgium in 2006 to that in 2008?
Provide a succinct answer. 0.88. What is the ratio of the Amount (in $) of Bhutan in 2006 to that in 2008?
Offer a very short reply. 0.75. What is the ratio of the Amount (in $) in Mali in 2006 to that in 2008?
Keep it short and to the point. 1.2. What is the ratio of the Amount (in $) of Netherlands in 2006 to that in 2008?
Provide a short and direct response. 0.9. What is the ratio of the Amount (in $) in Belgium in 2006 to that in 2009?
Give a very brief answer. 0.84. What is the ratio of the Amount (in $) in Bhutan in 2006 to that in 2009?
Make the answer very short. 0.79. What is the ratio of the Amount (in $) of Mali in 2006 to that in 2009?
Offer a very short reply. 0.97. What is the ratio of the Amount (in $) of Netherlands in 2006 to that in 2009?
Give a very brief answer. 0.84. What is the ratio of the Amount (in $) of Belgium in 2007 to that in 2008?
Make the answer very short. 0.93. What is the ratio of the Amount (in $) in Bhutan in 2007 to that in 2008?
Ensure brevity in your answer.  0.85. What is the ratio of the Amount (in $) in Mali in 2007 to that in 2008?
Give a very brief answer. 1.19. What is the ratio of the Amount (in $) in Netherlands in 2007 to that in 2008?
Offer a very short reply. 0.95. What is the ratio of the Amount (in $) in Belgium in 2007 to that in 2009?
Provide a succinct answer. 0.88. What is the ratio of the Amount (in $) in Bhutan in 2007 to that in 2009?
Make the answer very short. 0.89. What is the ratio of the Amount (in $) in Mali in 2007 to that in 2009?
Your answer should be compact. 0.96. What is the ratio of the Amount (in $) of Netherlands in 2007 to that in 2009?
Your answer should be very brief. 0.88. What is the ratio of the Amount (in $) of Belgium in 2008 to that in 2009?
Provide a succinct answer. 0.95. What is the ratio of the Amount (in $) in Bhutan in 2008 to that in 2009?
Your response must be concise. 1.05. What is the ratio of the Amount (in $) of Mali in 2008 to that in 2009?
Keep it short and to the point. 0.81. What is the ratio of the Amount (in $) of Netherlands in 2008 to that in 2009?
Your response must be concise. 0.93. What is the difference between the highest and the second highest Amount (in $) of Belgium?
Provide a succinct answer. 5.93e+09. What is the difference between the highest and the second highest Amount (in $) of Bhutan?
Provide a short and direct response. 2.35e+08. What is the difference between the highest and the second highest Amount (in $) of Mali?
Make the answer very short. 2.43e+09. What is the difference between the highest and the second highest Amount (in $) in Netherlands?
Offer a very short reply. 1.33e+1. What is the difference between the highest and the lowest Amount (in $) of Belgium?
Keep it short and to the point. 4.38e+1. What is the difference between the highest and the lowest Amount (in $) of Bhutan?
Offer a terse response. 3.51e+08. What is the difference between the highest and the lowest Amount (in $) of Mali?
Keep it short and to the point. 9.20e+1. What is the difference between the highest and the lowest Amount (in $) in Netherlands?
Offer a terse response. 8.04e+1. 